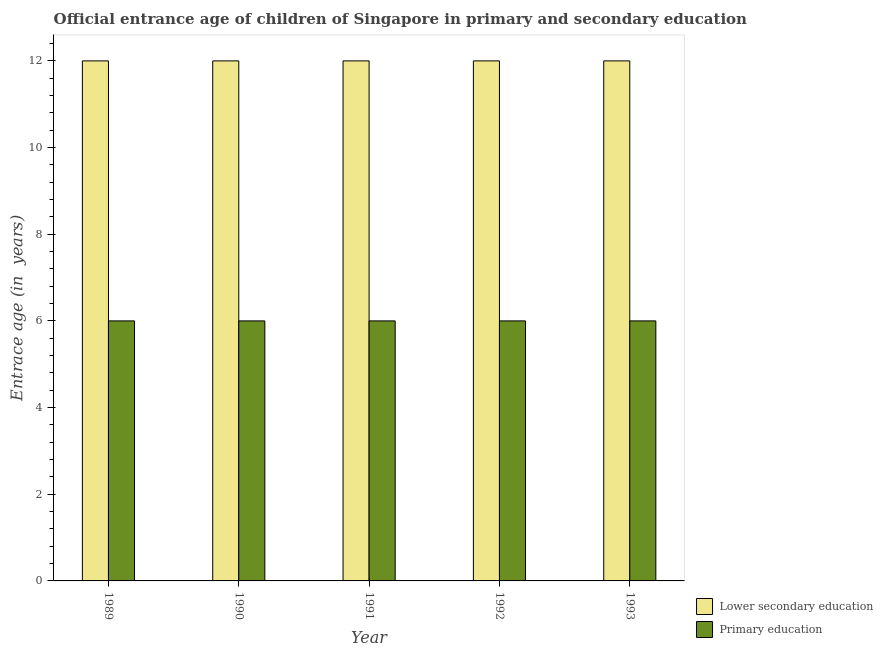How many different coloured bars are there?
Your response must be concise. 2. Are the number of bars per tick equal to the number of legend labels?
Offer a terse response. Yes. What is the label of the 5th group of bars from the left?
Your answer should be compact. 1993. In how many cases, is the number of bars for a given year not equal to the number of legend labels?
Ensure brevity in your answer.  0. What is the entrance age of children in lower secondary education in 1989?
Make the answer very short. 12. Across all years, what is the minimum entrance age of chiildren in primary education?
Your answer should be compact. 6. In which year was the entrance age of chiildren in primary education maximum?
Ensure brevity in your answer.  1989. What is the total entrance age of chiildren in primary education in the graph?
Keep it short and to the point. 30. What is the difference between the entrance age of chiildren in primary education in 1989 and that in 1992?
Keep it short and to the point. 0. What is the average entrance age of chiildren in primary education per year?
Provide a succinct answer. 6. What is the ratio of the entrance age of children in lower secondary education in 1989 to that in 1992?
Your response must be concise. 1. Is the entrance age of children in lower secondary education in 1992 less than that in 1993?
Offer a very short reply. No. What is the difference between the highest and the second highest entrance age of chiildren in primary education?
Offer a very short reply. 0. What is the difference between the highest and the lowest entrance age of children in lower secondary education?
Provide a short and direct response. 0. What does the 2nd bar from the right in 1993 represents?
Keep it short and to the point. Lower secondary education. Are all the bars in the graph horizontal?
Keep it short and to the point. No. Are the values on the major ticks of Y-axis written in scientific E-notation?
Keep it short and to the point. No. Does the graph contain any zero values?
Ensure brevity in your answer.  No. Where does the legend appear in the graph?
Make the answer very short. Bottom right. How are the legend labels stacked?
Give a very brief answer. Vertical. What is the title of the graph?
Give a very brief answer. Official entrance age of children of Singapore in primary and secondary education. Does "Long-term debt" appear as one of the legend labels in the graph?
Give a very brief answer. No. What is the label or title of the X-axis?
Offer a terse response. Year. What is the label or title of the Y-axis?
Your response must be concise. Entrace age (in  years). What is the Entrace age (in  years) of Lower secondary education in 1989?
Give a very brief answer. 12. What is the Entrace age (in  years) in Primary education in 1989?
Your answer should be very brief. 6. What is the Entrace age (in  years) of Lower secondary education in 1990?
Keep it short and to the point. 12. Across all years, what is the minimum Entrace age (in  years) in Lower secondary education?
Your answer should be very brief. 12. What is the total Entrace age (in  years) of Lower secondary education in the graph?
Ensure brevity in your answer.  60. What is the total Entrace age (in  years) of Primary education in the graph?
Provide a succinct answer. 30. What is the difference between the Entrace age (in  years) in Lower secondary education in 1989 and that in 1990?
Your response must be concise. 0. What is the difference between the Entrace age (in  years) of Lower secondary education in 1989 and that in 1992?
Give a very brief answer. 0. What is the difference between the Entrace age (in  years) in Primary education in 1989 and that in 1992?
Your answer should be compact. 0. What is the difference between the Entrace age (in  years) of Lower secondary education in 1989 and that in 1993?
Offer a terse response. 0. What is the difference between the Entrace age (in  years) of Primary education in 1989 and that in 1993?
Give a very brief answer. 0. What is the difference between the Entrace age (in  years) in Primary education in 1990 and that in 1991?
Give a very brief answer. 0. What is the difference between the Entrace age (in  years) of Lower secondary education in 1990 and that in 1992?
Offer a very short reply. 0. What is the difference between the Entrace age (in  years) of Lower secondary education in 1990 and that in 1993?
Your answer should be very brief. 0. What is the difference between the Entrace age (in  years) of Lower secondary education in 1991 and that in 1992?
Provide a succinct answer. 0. What is the difference between the Entrace age (in  years) in Primary education in 1991 and that in 1993?
Provide a succinct answer. 0. What is the difference between the Entrace age (in  years) of Primary education in 1992 and that in 1993?
Your response must be concise. 0. What is the difference between the Entrace age (in  years) in Lower secondary education in 1989 and the Entrace age (in  years) in Primary education in 1990?
Your answer should be compact. 6. What is the difference between the Entrace age (in  years) in Lower secondary education in 1990 and the Entrace age (in  years) in Primary education in 1991?
Provide a succinct answer. 6. What is the difference between the Entrace age (in  years) in Lower secondary education in 1990 and the Entrace age (in  years) in Primary education in 1992?
Your answer should be very brief. 6. What is the difference between the Entrace age (in  years) of Lower secondary education in 1990 and the Entrace age (in  years) of Primary education in 1993?
Keep it short and to the point. 6. What is the difference between the Entrace age (in  years) in Lower secondary education in 1991 and the Entrace age (in  years) in Primary education in 1992?
Your answer should be compact. 6. What is the difference between the Entrace age (in  years) of Lower secondary education in 1991 and the Entrace age (in  years) of Primary education in 1993?
Give a very brief answer. 6. What is the average Entrace age (in  years) of Primary education per year?
Make the answer very short. 6. In the year 1989, what is the difference between the Entrace age (in  years) in Lower secondary education and Entrace age (in  years) in Primary education?
Your answer should be very brief. 6. In the year 1992, what is the difference between the Entrace age (in  years) in Lower secondary education and Entrace age (in  years) in Primary education?
Ensure brevity in your answer.  6. In the year 1993, what is the difference between the Entrace age (in  years) in Lower secondary education and Entrace age (in  years) in Primary education?
Offer a terse response. 6. What is the ratio of the Entrace age (in  years) in Primary education in 1989 to that in 1990?
Offer a very short reply. 1. What is the ratio of the Entrace age (in  years) in Lower secondary education in 1989 to that in 1991?
Provide a succinct answer. 1. What is the ratio of the Entrace age (in  years) in Lower secondary education in 1989 to that in 1992?
Make the answer very short. 1. What is the ratio of the Entrace age (in  years) in Lower secondary education in 1989 to that in 1993?
Ensure brevity in your answer.  1. What is the ratio of the Entrace age (in  years) of Primary education in 1989 to that in 1993?
Your answer should be very brief. 1. What is the ratio of the Entrace age (in  years) of Lower secondary education in 1990 to that in 1993?
Make the answer very short. 1. What is the ratio of the Entrace age (in  years) of Lower secondary education in 1991 to that in 1992?
Keep it short and to the point. 1. What is the ratio of the Entrace age (in  years) of Primary education in 1991 to that in 1992?
Provide a short and direct response. 1. What is the ratio of the Entrace age (in  years) in Lower secondary education in 1991 to that in 1993?
Offer a terse response. 1. What is the difference between the highest and the lowest Entrace age (in  years) of Primary education?
Provide a succinct answer. 0. 